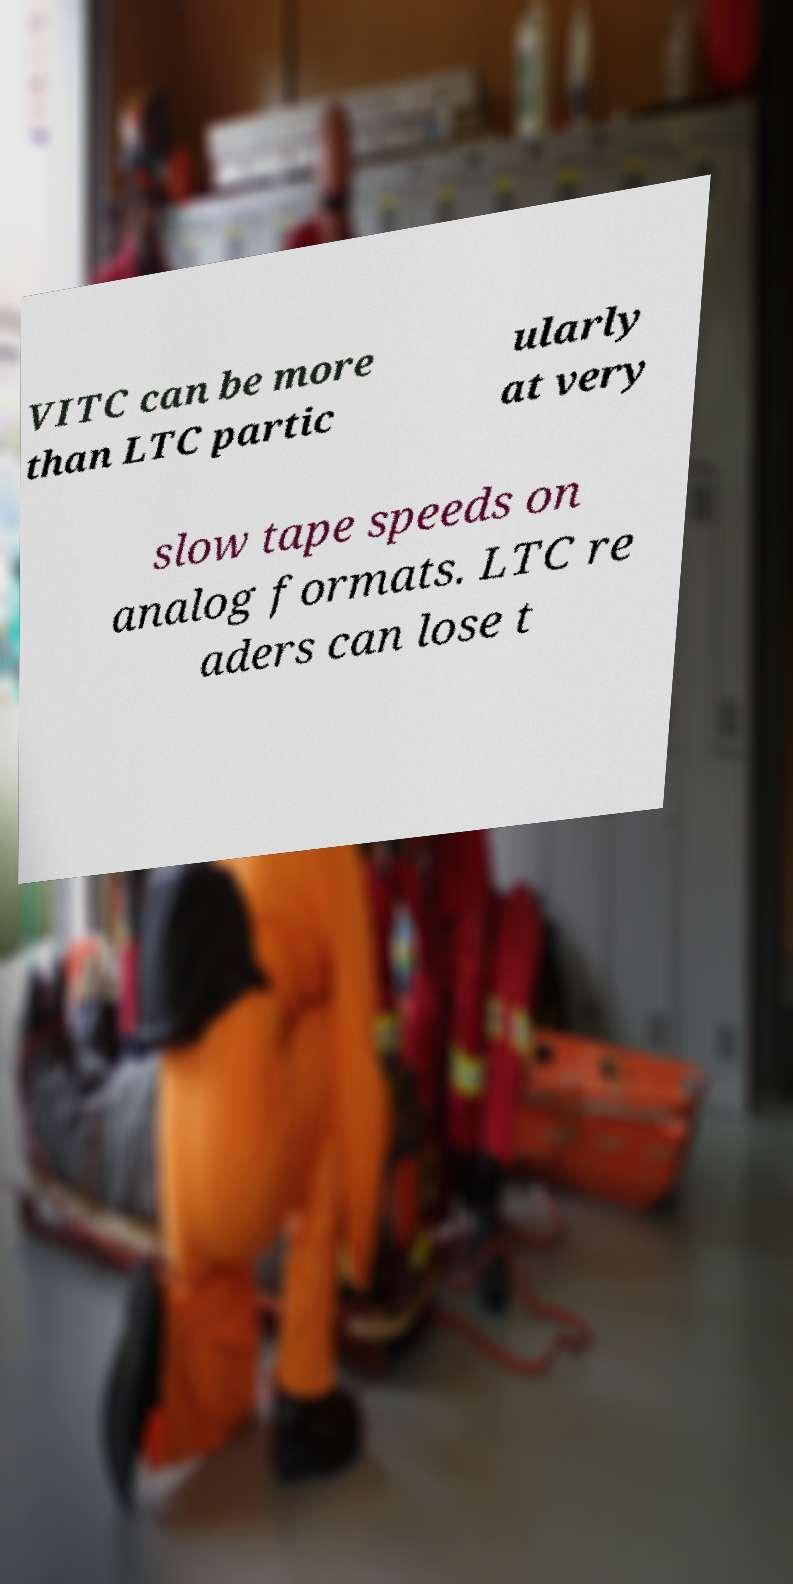Could you extract and type out the text from this image? VITC can be more than LTC partic ularly at very slow tape speeds on analog formats. LTC re aders can lose t 